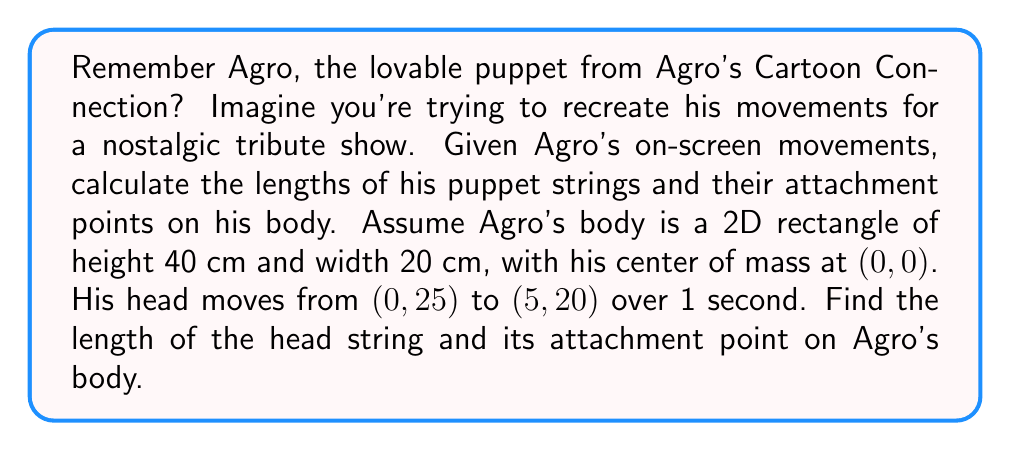Show me your answer to this math problem. Let's approach this step-by-step, reminiscing about Agro's playful movements:

1) First, we need to determine the displacement vector of Agro's head:
   $$\vec{d} = (5-0, 20-25) = (5, -5)$$

2) The magnitude of this displacement is:
   $$|\vec{d}| = \sqrt{5^2 + (-5)^2} = \sqrt{50} \approx 7.07 \text{ cm}$$

3) Assuming the string moves in a circular arc, we can use the chord length formula to find the radius (r) of this circle:
   $$r = \frac{|\vec{d}|^2}{8h} + \frac{h}{2}$$
   where h is the height of the circular segment.

4) We can estimate h as half the vertical displacement:
   $$h = \frac{5}{2} = 2.5 \text{ cm}$$

5) Now we can calculate r:
   $$r = \frac{50}{8(2.5)} + \frac{2.5}{2} = 2.5 + 1.25 = 3.75 \text{ cm}$$

6) The string length is this radius: 3.75 cm

7) To find the attachment point, we need to find where this circle intersects Agro's body. The center of the circle will be directly above the midpoint of the chord:
   Midpoint of chord: $(\frac{0+5}{2}, \frac{25+20}{2}) = (2.5, 22.5)$

8) The center of the circle is 3.75 cm above this point:
   $$(2.5, 22.5 + 3.75) = (2.5, 26.25)$$

9) This point is above Agro's body, so the string attaches at the top of his body, 2.5 cm to the right of his center.
Answer: String length: 3.75 cm; Attachment point: (2.5, 20) cm 